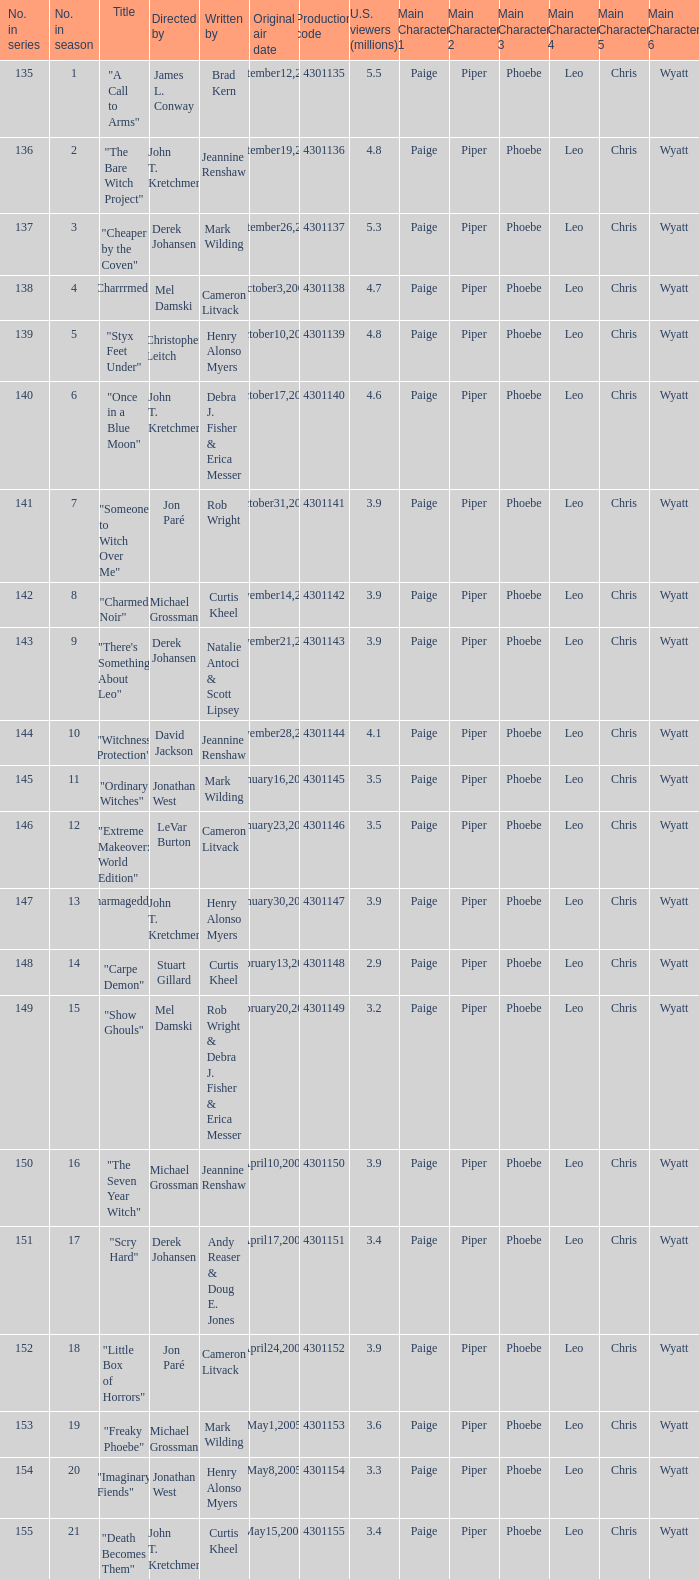Could you help me parse every detail presented in this table? {'header': ['No. in series', 'No. in season', 'Title', 'Directed by', 'Written by', 'Original air date', 'Production code', 'U.S. viewers (millions)', 'Main Character 1', 'Main Character 2', 'Main Character 3', 'Main Character 4', 'Main Character 5', 'Main Character 6'], 'rows': [['135', '1', '"A Call to Arms"', 'James L. Conway', 'Brad Kern', 'September12,2004', '4301135', '5.5', 'Paige', 'Piper', 'Phoebe', 'Leo', 'Chris', 'Wyatt'], ['136', '2', '"The Bare Witch Project"', 'John T. Kretchmer', 'Jeannine Renshaw', 'September19,2004', '4301136', '4.8', 'Paige', 'Piper', 'Phoebe', 'Leo', 'Chris', 'Wyatt'], ['137', '3', '"Cheaper by the Coven"', 'Derek Johansen', 'Mark Wilding', 'September26,2004', '4301137', '5.3', 'Paige', 'Piper', 'Phoebe', 'Leo', 'Chris', 'Wyatt'], ['138', '4', '"Charrrmed!"', 'Mel Damski', 'Cameron Litvack', 'October3,2004', '4301138', '4.7', 'Paige', 'Piper', 'Phoebe', 'Leo', 'Chris', 'Wyatt'], ['139', '5', '"Styx Feet Under"', 'Christopher Leitch', 'Henry Alonso Myers', 'October10,2004', '4301139', '4.8', 'Paige', 'Piper', 'Phoebe', 'Leo', 'Chris', 'Wyatt'], ['140', '6', '"Once in a Blue Moon"', 'John T. Kretchmer', 'Debra J. Fisher & Erica Messer', 'October17,2004', '4301140', '4.6', 'Paige', 'Piper', 'Phoebe', 'Leo', 'Chris', 'Wyatt'], ['141', '7', '"Someone to Witch Over Me"', 'Jon Paré', 'Rob Wright', 'October31,2004', '4301141', '3.9', 'Paige', 'Piper', 'Phoebe', 'Leo', 'Chris', 'Wyatt'], ['142', '8', '"Charmed Noir"', 'Michael Grossman', 'Curtis Kheel', 'November14,2004', '4301142', '3.9', 'Paige', 'Piper', 'Phoebe', 'Leo', 'Chris', 'Wyatt'], ['143', '9', '"There\'s Something About Leo"', 'Derek Johansen', 'Natalie Antoci & Scott Lipsey', 'November21,2004', '4301143', '3.9', 'Paige', 'Piper', 'Phoebe', 'Leo', 'Chris', 'Wyatt'], ['144', '10', '"Witchness Protection"', 'David Jackson', 'Jeannine Renshaw', 'November28,2004', '4301144', '4.1', 'Paige', 'Piper', 'Phoebe', 'Leo', 'Chris', 'Wyatt'], ['145', '11', '"Ordinary Witches"', 'Jonathan West', 'Mark Wilding', 'January16,2005', '4301145', '3.5', 'Paige', 'Piper', 'Phoebe', 'Leo', 'Chris', 'Wyatt'], ['146', '12', '"Extreme Makeover: World Edition"', 'LeVar Burton', 'Cameron Litvack', 'January23,2005', '4301146', '3.5', 'Paige', 'Piper', 'Phoebe', 'Leo', 'Chris', 'Wyatt'], ['147', '13', '"Charmageddon"', 'John T. Kretchmer', 'Henry Alonso Myers', 'January30,2005', '4301147', '3.9', 'Paige', 'Piper', 'Phoebe', 'Leo', 'Chris', 'Wyatt'], ['148', '14', '"Carpe Demon"', 'Stuart Gillard', 'Curtis Kheel', 'February13,2005', '4301148', '2.9', 'Paige', 'Piper', 'Phoebe', 'Leo', 'Chris', 'Wyatt'], ['149', '15', '"Show Ghouls"', 'Mel Damski', 'Rob Wright & Debra J. Fisher & Erica Messer', 'February20,2005', '4301149', '3.2', 'Paige', 'Piper', 'Phoebe', 'Leo', 'Chris', 'Wyatt'], ['150', '16', '"The Seven Year Witch"', 'Michael Grossman', 'Jeannine Renshaw', 'April10,2005', '4301150', '3.9', 'Paige', 'Piper', 'Phoebe', 'Leo', 'Chris', 'Wyatt'], ['151', '17', '"Scry Hard"', 'Derek Johansen', 'Andy Reaser & Doug E. Jones', 'April17,2005', '4301151', '3.4', 'Paige', 'Piper', 'Phoebe', 'Leo', 'Chris', 'Wyatt'], ['152', '18', '"Little Box of Horrors"', 'Jon Paré', 'Cameron Litvack', 'April24,2005', '4301152', '3.9', 'Paige', 'Piper', 'Phoebe', 'Leo', 'Chris', 'Wyatt'], ['153', '19', '"Freaky Phoebe"', 'Michael Grossman', 'Mark Wilding', 'May1,2005', '4301153', '3.6', 'Paige', 'Piper', 'Phoebe', 'Leo', 'Chris', 'Wyatt'], ['154', '20', '"Imaginary Fiends"', 'Jonathan West', 'Henry Alonso Myers', 'May8,2005', '4301154', '3.3', 'Paige', 'Piper', 'Phoebe', 'Leo', 'Chris', 'Wyatt'], ['155', '21', '"Death Becomes Them"', 'John T. Kretchmer', 'Curtis Kheel', 'May15,2005', '4301155', '3.4', 'Paige', 'Piper', 'Phoebe', 'Leo', 'Chris', 'Wyatt']]} When the writer is brad kern, how many u.s viewers (in millions) had the episode? 5.5. 